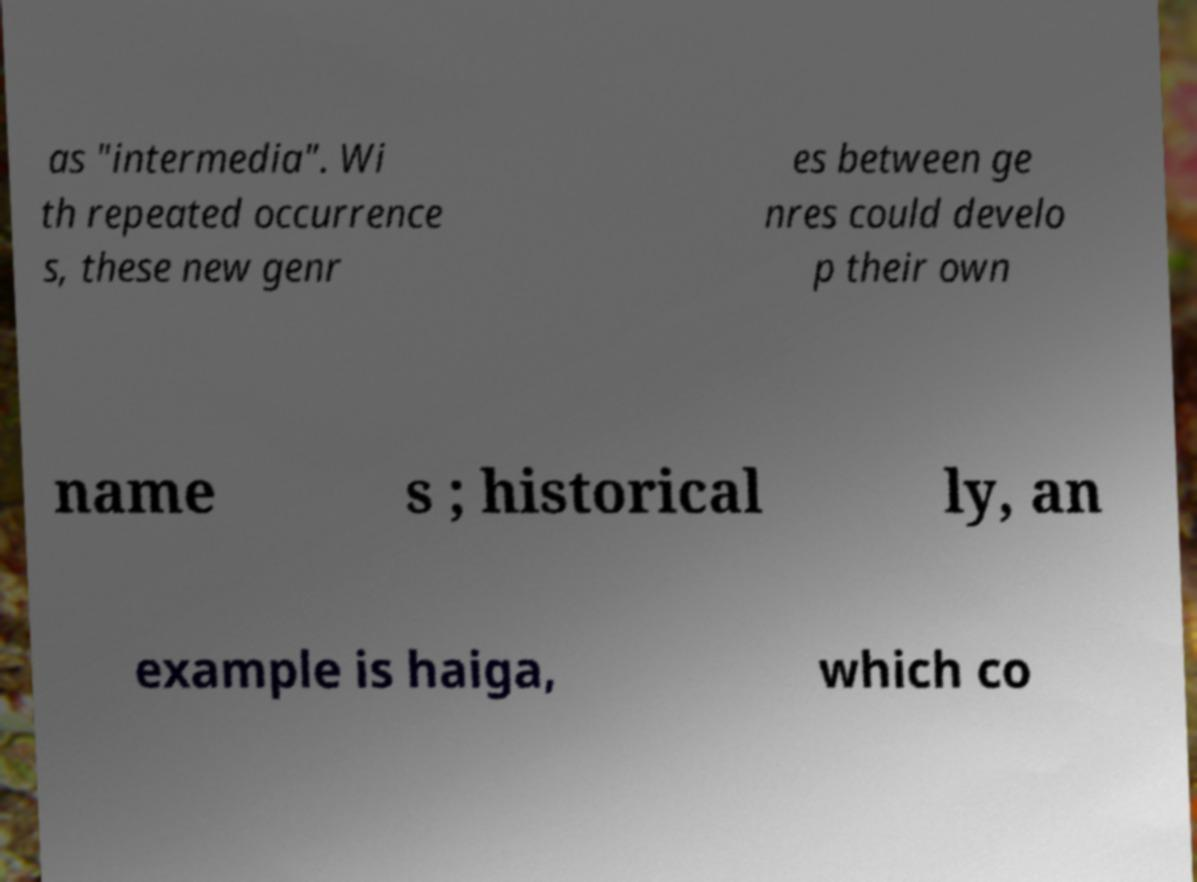Could you extract and type out the text from this image? as "intermedia". Wi th repeated occurrence s, these new genr es between ge nres could develo p their own name s ; historical ly, an example is haiga, which co 